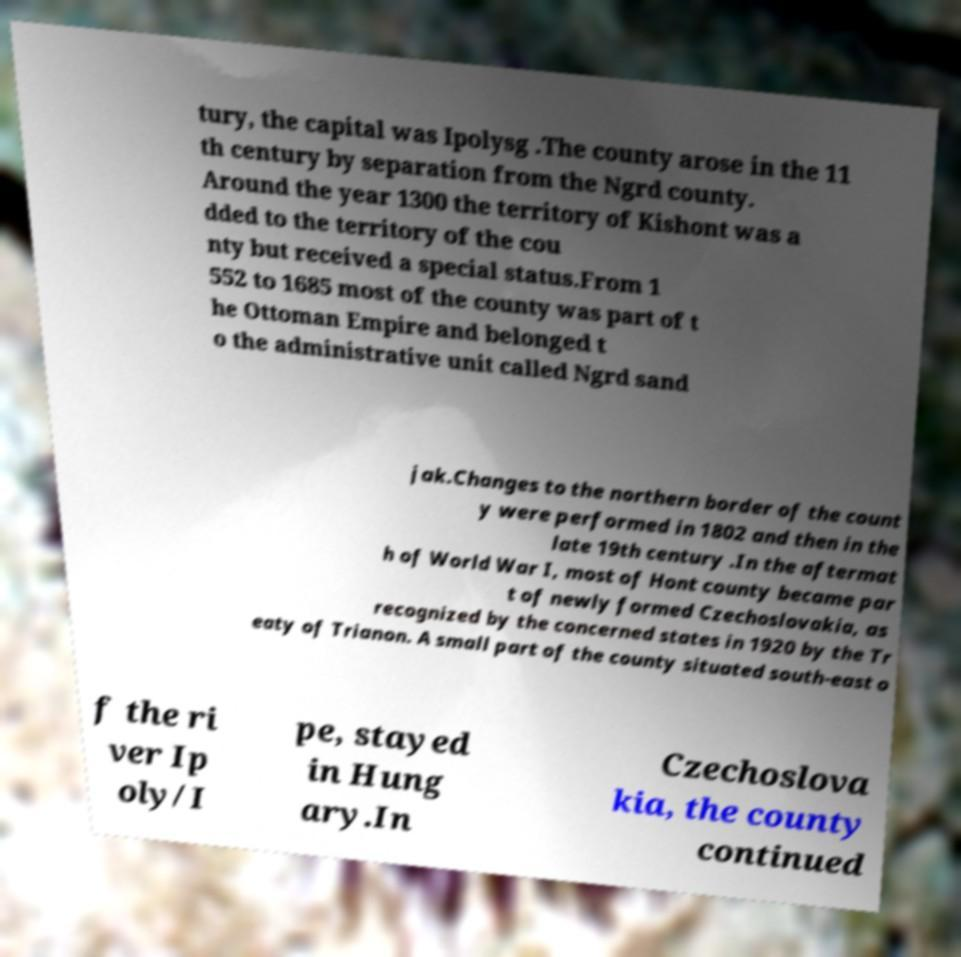Can you read and provide the text displayed in the image?This photo seems to have some interesting text. Can you extract and type it out for me? tury, the capital was Ipolysg .The county arose in the 11 th century by separation from the Ngrd county. Around the year 1300 the territory of Kishont was a dded to the territory of the cou nty but received a special status.From 1 552 to 1685 most of the county was part of t he Ottoman Empire and belonged t o the administrative unit called Ngrd sand jak.Changes to the northern border of the count y were performed in 1802 and then in the late 19th century .In the aftermat h of World War I, most of Hont county became par t of newly formed Czechoslovakia, as recognized by the concerned states in 1920 by the Tr eaty of Trianon. A small part of the county situated south-east o f the ri ver Ip oly/I pe, stayed in Hung ary.In Czechoslova kia, the county continued 